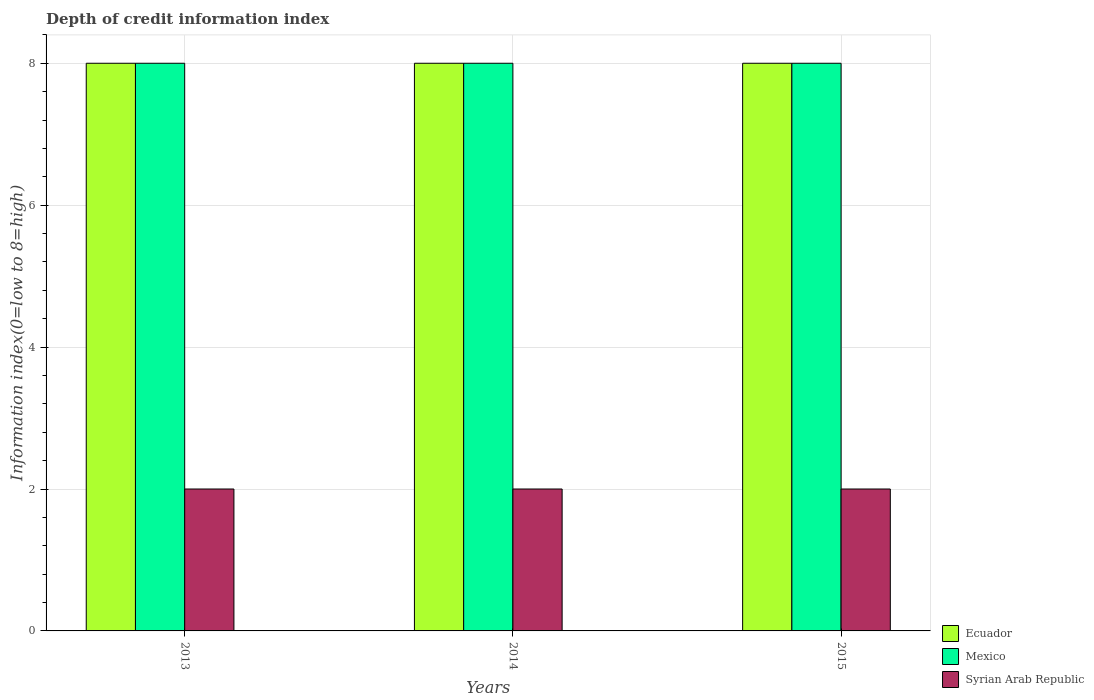How many groups of bars are there?
Provide a succinct answer. 3. Are the number of bars on each tick of the X-axis equal?
Your answer should be very brief. Yes. What is the label of the 2nd group of bars from the left?
Offer a terse response. 2014. What is the information index in Ecuador in 2013?
Your answer should be compact. 8. Across all years, what is the maximum information index in Syrian Arab Republic?
Your answer should be compact. 2. Across all years, what is the minimum information index in Syrian Arab Republic?
Provide a short and direct response. 2. In which year was the information index in Mexico maximum?
Ensure brevity in your answer.  2013. In which year was the information index in Ecuador minimum?
Your response must be concise. 2013. What is the total information index in Mexico in the graph?
Provide a succinct answer. 24. Is the information index in Ecuador in 2013 less than that in 2014?
Your response must be concise. No. Is the difference between the information index in Ecuador in 2013 and 2014 greater than the difference between the information index in Syrian Arab Republic in 2013 and 2014?
Your answer should be compact. No. What is the difference between the highest and the second highest information index in Ecuador?
Make the answer very short. 0. What is the difference between the highest and the lowest information index in Syrian Arab Republic?
Provide a short and direct response. 0. Is the sum of the information index in Syrian Arab Republic in 2014 and 2015 greater than the maximum information index in Mexico across all years?
Offer a very short reply. No. What does the 1st bar from the left in 2013 represents?
Offer a very short reply. Ecuador. What does the 1st bar from the right in 2014 represents?
Keep it short and to the point. Syrian Arab Republic. Is it the case that in every year, the sum of the information index in Mexico and information index in Ecuador is greater than the information index in Syrian Arab Republic?
Provide a succinct answer. Yes. How many years are there in the graph?
Keep it short and to the point. 3. Does the graph contain grids?
Offer a very short reply. Yes. Where does the legend appear in the graph?
Your response must be concise. Bottom right. How many legend labels are there?
Keep it short and to the point. 3. What is the title of the graph?
Your answer should be very brief. Depth of credit information index. What is the label or title of the Y-axis?
Offer a terse response. Information index(0=low to 8=high). What is the Information index(0=low to 8=high) in Mexico in 2013?
Offer a very short reply. 8. What is the Information index(0=low to 8=high) in Syrian Arab Republic in 2013?
Give a very brief answer. 2. What is the Information index(0=low to 8=high) of Mexico in 2014?
Provide a succinct answer. 8. What is the Information index(0=low to 8=high) in Syrian Arab Republic in 2014?
Give a very brief answer. 2. What is the Information index(0=low to 8=high) in Ecuador in 2015?
Provide a short and direct response. 8. What is the Information index(0=low to 8=high) in Mexico in 2015?
Offer a very short reply. 8. Across all years, what is the maximum Information index(0=low to 8=high) in Mexico?
Provide a short and direct response. 8. Across all years, what is the maximum Information index(0=low to 8=high) in Syrian Arab Republic?
Offer a very short reply. 2. Across all years, what is the minimum Information index(0=low to 8=high) in Syrian Arab Republic?
Your answer should be compact. 2. What is the total Information index(0=low to 8=high) of Ecuador in the graph?
Your answer should be compact. 24. What is the total Information index(0=low to 8=high) in Syrian Arab Republic in the graph?
Ensure brevity in your answer.  6. What is the difference between the Information index(0=low to 8=high) in Ecuador in 2013 and that in 2014?
Provide a short and direct response. 0. What is the difference between the Information index(0=low to 8=high) in Mexico in 2013 and that in 2014?
Provide a succinct answer. 0. What is the difference between the Information index(0=low to 8=high) of Syrian Arab Republic in 2013 and that in 2014?
Your answer should be compact. 0. What is the difference between the Information index(0=low to 8=high) in Mexico in 2014 and that in 2015?
Ensure brevity in your answer.  0. What is the difference between the Information index(0=low to 8=high) in Syrian Arab Republic in 2014 and that in 2015?
Keep it short and to the point. 0. What is the difference between the Information index(0=low to 8=high) in Ecuador in 2013 and the Information index(0=low to 8=high) in Mexico in 2015?
Provide a succinct answer. 0. What is the difference between the Information index(0=low to 8=high) of Ecuador in 2014 and the Information index(0=low to 8=high) of Mexico in 2015?
Your answer should be compact. 0. What is the difference between the Information index(0=low to 8=high) in Ecuador in 2014 and the Information index(0=low to 8=high) in Syrian Arab Republic in 2015?
Offer a very short reply. 6. What is the difference between the Information index(0=low to 8=high) of Mexico in 2014 and the Information index(0=low to 8=high) of Syrian Arab Republic in 2015?
Make the answer very short. 6. What is the average Information index(0=low to 8=high) of Ecuador per year?
Give a very brief answer. 8. In the year 2013, what is the difference between the Information index(0=low to 8=high) in Mexico and Information index(0=low to 8=high) in Syrian Arab Republic?
Provide a short and direct response. 6. In the year 2014, what is the difference between the Information index(0=low to 8=high) of Ecuador and Information index(0=low to 8=high) of Syrian Arab Republic?
Give a very brief answer. 6. In the year 2014, what is the difference between the Information index(0=low to 8=high) in Mexico and Information index(0=low to 8=high) in Syrian Arab Republic?
Your response must be concise. 6. In the year 2015, what is the difference between the Information index(0=low to 8=high) in Ecuador and Information index(0=low to 8=high) in Mexico?
Offer a very short reply. 0. In the year 2015, what is the difference between the Information index(0=low to 8=high) of Ecuador and Information index(0=low to 8=high) of Syrian Arab Republic?
Your answer should be very brief. 6. What is the ratio of the Information index(0=low to 8=high) in Syrian Arab Republic in 2013 to that in 2014?
Your answer should be compact. 1. What is the ratio of the Information index(0=low to 8=high) of Ecuador in 2013 to that in 2015?
Your answer should be very brief. 1. What is the ratio of the Information index(0=low to 8=high) in Mexico in 2013 to that in 2015?
Make the answer very short. 1. What is the ratio of the Information index(0=low to 8=high) in Syrian Arab Republic in 2013 to that in 2015?
Provide a succinct answer. 1. What is the ratio of the Information index(0=low to 8=high) in Ecuador in 2014 to that in 2015?
Your answer should be compact. 1. What is the ratio of the Information index(0=low to 8=high) in Mexico in 2014 to that in 2015?
Your answer should be compact. 1. What is the ratio of the Information index(0=low to 8=high) of Syrian Arab Republic in 2014 to that in 2015?
Offer a very short reply. 1. What is the difference between the highest and the second highest Information index(0=low to 8=high) in Mexico?
Offer a very short reply. 0. What is the difference between the highest and the second highest Information index(0=low to 8=high) in Syrian Arab Republic?
Your response must be concise. 0. 